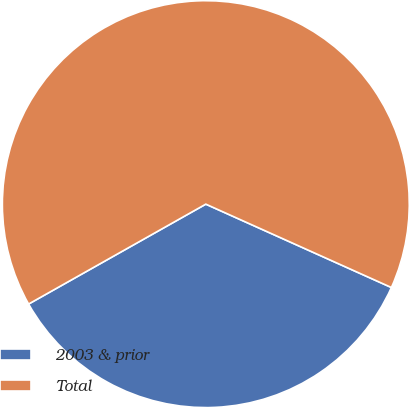Convert chart to OTSL. <chart><loc_0><loc_0><loc_500><loc_500><pie_chart><fcel>2003 & prior<fcel>Total<nl><fcel>35.11%<fcel>64.89%<nl></chart> 